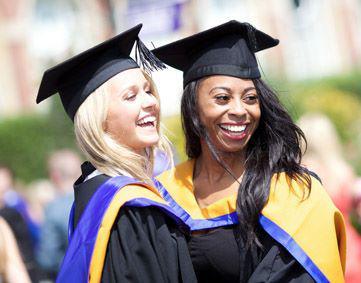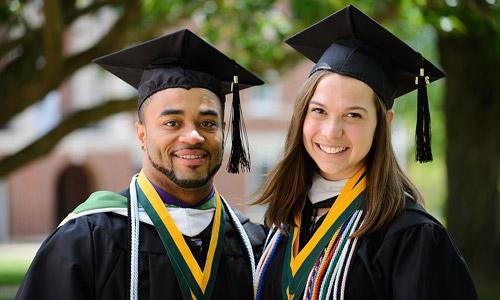The first image is the image on the left, the second image is the image on the right. Considering the images on both sides, is "An image shows a nonwhite male graduate standing on the left and a white female standing on the right." valid? Answer yes or no. Yes. The first image is the image on the left, the second image is the image on the right. Analyze the images presented: Is the assertion "Each image focuses on two smiling graduates wearing black gowns and mortarboards with a tassel hanging from each." valid? Answer yes or no. Yes. 